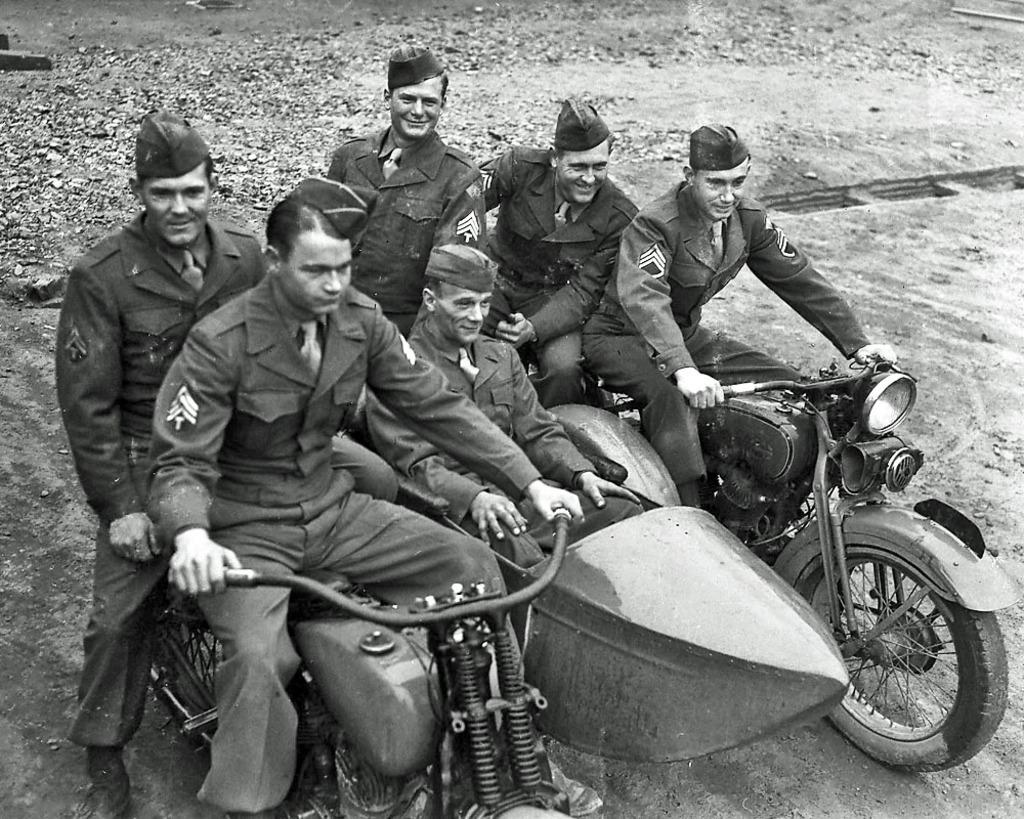What is the color scheme of the image? The image is black and white. Who is present in the image? There are men in the image. What are the men doing in the image? The men are sitting on bikes. What expression do the men have in the image? The men are smiling. Where is the scene taking place? The setting is a road. What type of grape can be seen hanging from the lace in the image? There is no grape or lace present in the image. 